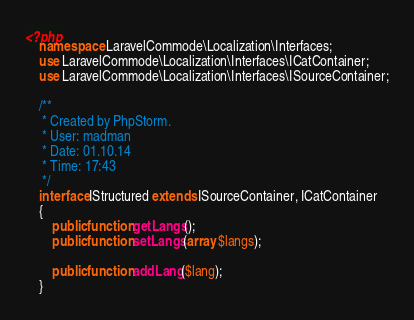Convert code to text. <code><loc_0><loc_0><loc_500><loc_500><_PHP_><?php
    namespace LaravelCommode\Localization\Interfaces;
    use LaravelCommode\Localization\Interfaces\ICatContainer;
    use LaravelCommode\Localization\Interfaces\ISourceContainer;

    /**
     * Created by PhpStorm.
     * User: madman
     * Date: 01.10.14
     * Time: 17:43
     */
    interface IStructured extends ISourceContainer, ICatContainer
    {
        public function getLangs();
        public function setLangs(array $langs);

        public function addLang($lang);
    } </code> 